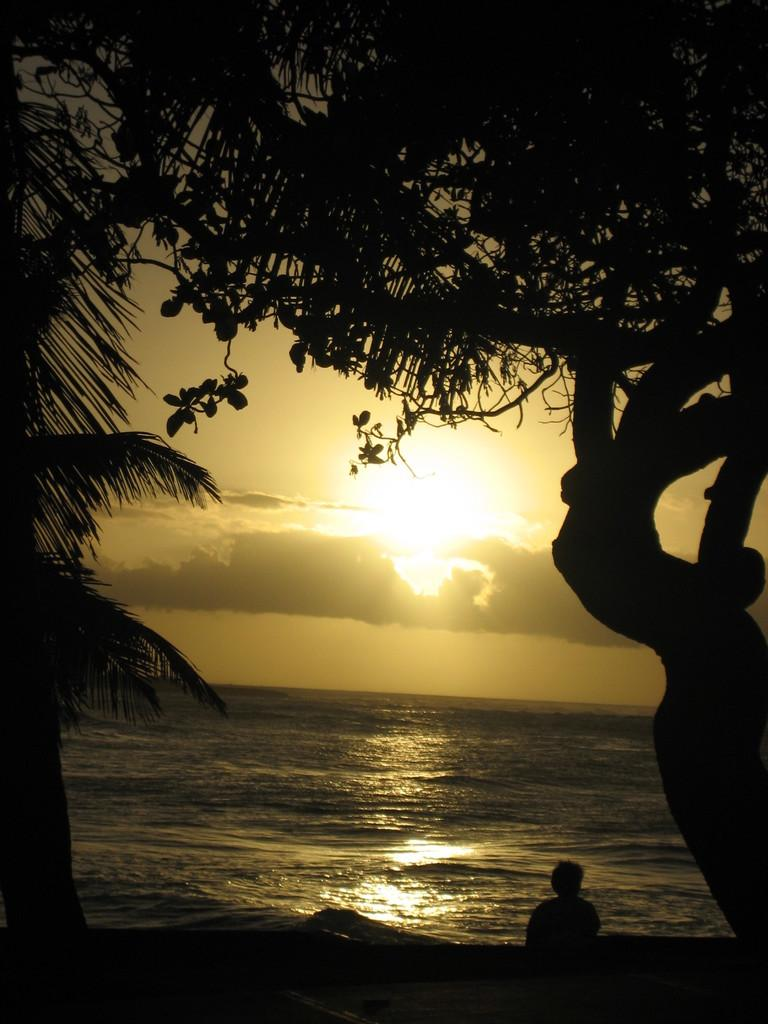Who or what is located at the bottom of the image? There is a person at the bottom of the image. What can be seen in the middle of the image? There are trees, water, the sun, clouds, and the sky visible in the middle of the image. Can you describe the natural elements present in the image? The image features trees, water, and the sky. Where is the library located in the image? There is no library present in the image. How many babies are visible in the image? There are no babies visible in the image. 